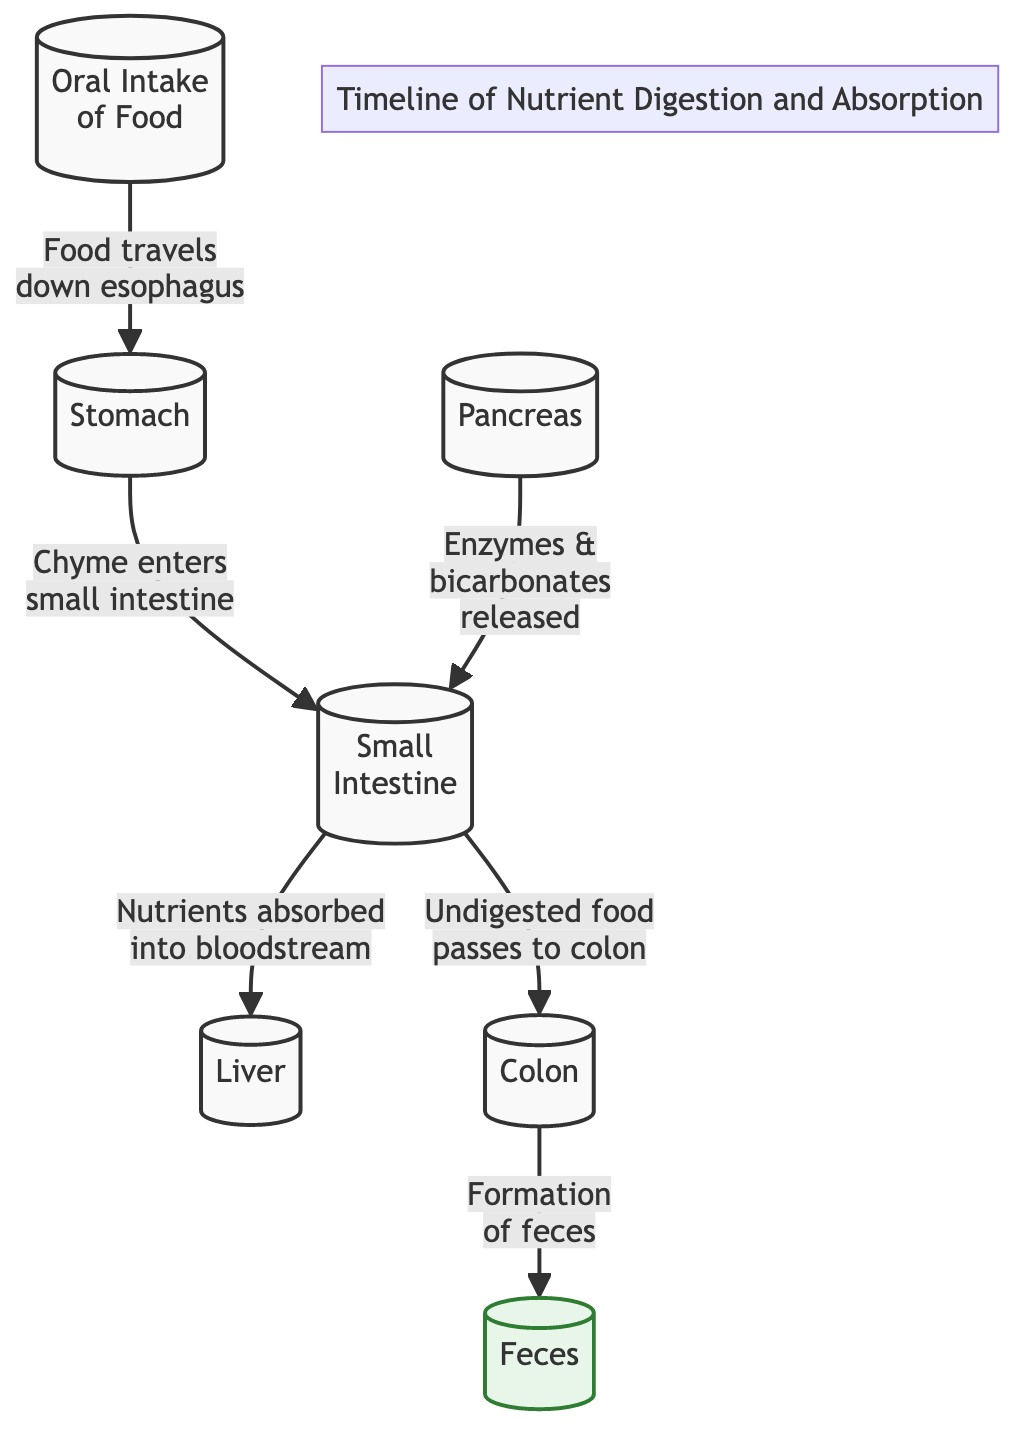What is the first step in the nutrient digestion process? The diagram indicates that the first step in the nutrient digestion process is "Oral Intake of Food." This is the starting point before any digestion begins.
Answer: Oral Intake of Food What organ receives nutrients after absorption in the small intestine? According to the diagram, the liver is the organ that receives nutrients after they are absorbed into the bloodstream from the small intestine.
Answer: Liver How many total nodes are there in the diagram? By counting each distinct function or organ illustrated in the diagram, we identify a total of six nodes: Oral Intake, Stomach, Small Intestine, Pancreas, Liver, and Colon.
Answer: Six Which organ contributes enzymes to aid in digestion? The diagram specifies that the pancreas releases enzymes and bicarbonates to the small intestine, which are crucial for digestion.
Answer: Pancreas What process occurs in the colon? The diagram shows that in the colon, the formation of feces occurs as the final stage of the digestive process.
Answer: Formation of feces What happens to undigested food according to the diagram? The flow from the small intestine directs undigested food to the colon, indicating that it passes there after nutrient absorption.
Answer: Passes to colon Which organ is responsible for releasing enzymes and bicarbonates? The diagram clearly states that the pancreas is responsible for the release of enzymes and bicarbonates that assist in digestion.
Answer: Pancreas In what order do nutrients travel from oral intake to feces? Following the arrows in the diagram, the order is Oral Intake → Stomach → Small Intestine → Liver/Colon → Feces, illustrating the full digestive pathway.
Answer: Oral Intake, Stomach, Small Intestine, Liver/Colon, Feces How does food move from the stomach to the small intestine? The diagram depicts that food moves from the stomach to the small intestine as a mixture called chyme, which is generated during the digestive process.
Answer: Chyme enters small intestine 